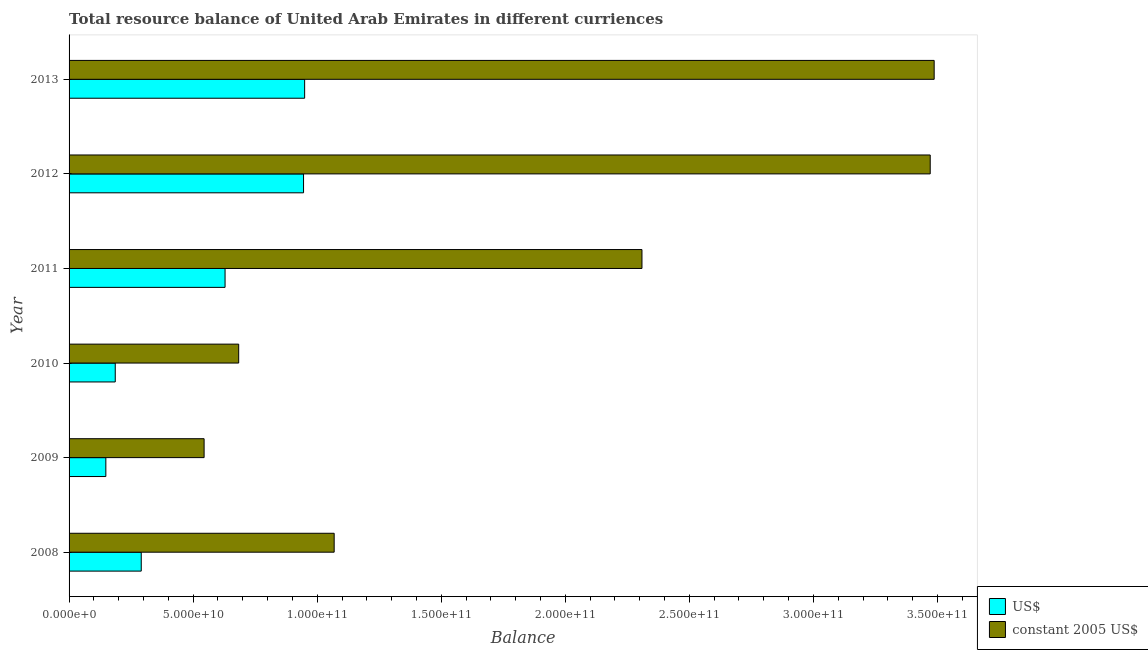How many different coloured bars are there?
Keep it short and to the point. 2. How many groups of bars are there?
Give a very brief answer. 6. What is the label of the 1st group of bars from the top?
Give a very brief answer. 2013. In how many cases, is the number of bars for a given year not equal to the number of legend labels?
Offer a terse response. 0. What is the resource balance in constant us$ in 2012?
Your answer should be compact. 3.47e+11. Across all years, what is the maximum resource balance in us$?
Make the answer very short. 9.49e+1. Across all years, what is the minimum resource balance in constant us$?
Provide a short and direct response. 5.44e+1. In which year was the resource balance in constant us$ minimum?
Make the answer very short. 2009. What is the total resource balance in us$ in the graph?
Provide a short and direct response. 3.15e+11. What is the difference between the resource balance in us$ in 2008 and that in 2012?
Your answer should be compact. -6.54e+1. What is the difference between the resource balance in constant us$ in 2011 and the resource balance in us$ in 2012?
Your response must be concise. 1.36e+11. What is the average resource balance in us$ per year?
Make the answer very short. 5.25e+1. In the year 2013, what is the difference between the resource balance in constant us$ and resource balance in us$?
Provide a short and direct response. 2.54e+11. In how many years, is the resource balance in us$ greater than 180000000000 units?
Provide a succinct answer. 0. What is the ratio of the resource balance in constant us$ in 2010 to that in 2013?
Provide a short and direct response. 0.2. Is the resource balance in us$ in 2008 less than that in 2013?
Ensure brevity in your answer.  Yes. What is the difference between the highest and the second highest resource balance in constant us$?
Keep it short and to the point. 1.60e+09. What is the difference between the highest and the lowest resource balance in constant us$?
Provide a short and direct response. 2.94e+11. In how many years, is the resource balance in us$ greater than the average resource balance in us$ taken over all years?
Your answer should be compact. 3. What does the 1st bar from the top in 2010 represents?
Offer a very short reply. Constant 2005 us$. What does the 1st bar from the bottom in 2009 represents?
Offer a terse response. US$. What is the difference between two consecutive major ticks on the X-axis?
Your answer should be compact. 5.00e+1. Does the graph contain any zero values?
Provide a succinct answer. No. Does the graph contain grids?
Offer a very short reply. No. Where does the legend appear in the graph?
Give a very brief answer. Bottom right. How many legend labels are there?
Keep it short and to the point. 2. How are the legend labels stacked?
Give a very brief answer. Vertical. What is the title of the graph?
Offer a very short reply. Total resource balance of United Arab Emirates in different curriences. Does "Investment" appear as one of the legend labels in the graph?
Provide a succinct answer. No. What is the label or title of the X-axis?
Provide a succinct answer. Balance. What is the Balance in US$ in 2008?
Your answer should be compact. 2.91e+1. What is the Balance of constant 2005 US$ in 2008?
Ensure brevity in your answer.  1.07e+11. What is the Balance of US$ in 2009?
Your answer should be compact. 1.48e+1. What is the Balance of constant 2005 US$ in 2009?
Ensure brevity in your answer.  5.44e+1. What is the Balance in US$ in 2010?
Your response must be concise. 1.86e+1. What is the Balance in constant 2005 US$ in 2010?
Offer a terse response. 6.84e+1. What is the Balance of US$ in 2011?
Your response must be concise. 6.29e+1. What is the Balance of constant 2005 US$ in 2011?
Ensure brevity in your answer.  2.31e+11. What is the Balance of US$ in 2012?
Offer a very short reply. 9.45e+1. What is the Balance of constant 2005 US$ in 2012?
Ensure brevity in your answer.  3.47e+11. What is the Balance in US$ in 2013?
Your answer should be compact. 9.49e+1. What is the Balance in constant 2005 US$ in 2013?
Offer a terse response. 3.49e+11. Across all years, what is the maximum Balance in US$?
Your response must be concise. 9.49e+1. Across all years, what is the maximum Balance of constant 2005 US$?
Give a very brief answer. 3.49e+11. Across all years, what is the minimum Balance in US$?
Offer a terse response. 1.48e+1. Across all years, what is the minimum Balance of constant 2005 US$?
Offer a terse response. 5.44e+1. What is the total Balance of US$ in the graph?
Your answer should be compact. 3.15e+11. What is the total Balance in constant 2005 US$ in the graph?
Your response must be concise. 1.16e+12. What is the difference between the Balance in US$ in 2008 and that in 2009?
Offer a very short reply. 1.43e+1. What is the difference between the Balance of constant 2005 US$ in 2008 and that in 2009?
Your answer should be very brief. 5.24e+1. What is the difference between the Balance in US$ in 2008 and that in 2010?
Your response must be concise. 1.05e+1. What is the difference between the Balance in constant 2005 US$ in 2008 and that in 2010?
Your answer should be compact. 3.85e+1. What is the difference between the Balance in US$ in 2008 and that in 2011?
Your answer should be compact. -3.38e+1. What is the difference between the Balance in constant 2005 US$ in 2008 and that in 2011?
Make the answer very short. -1.24e+11. What is the difference between the Balance of US$ in 2008 and that in 2012?
Your answer should be compact. -6.54e+1. What is the difference between the Balance of constant 2005 US$ in 2008 and that in 2012?
Provide a short and direct response. -2.40e+11. What is the difference between the Balance of US$ in 2008 and that in 2013?
Provide a short and direct response. -6.58e+1. What is the difference between the Balance in constant 2005 US$ in 2008 and that in 2013?
Offer a terse response. -2.42e+11. What is the difference between the Balance of US$ in 2009 and that in 2010?
Your response must be concise. -3.79e+09. What is the difference between the Balance of constant 2005 US$ in 2009 and that in 2010?
Ensure brevity in your answer.  -1.39e+1. What is the difference between the Balance in US$ in 2009 and that in 2011?
Keep it short and to the point. -4.81e+1. What is the difference between the Balance in constant 2005 US$ in 2009 and that in 2011?
Your answer should be compact. -1.76e+11. What is the difference between the Balance of US$ in 2009 and that in 2012?
Give a very brief answer. -7.97e+1. What is the difference between the Balance of constant 2005 US$ in 2009 and that in 2012?
Provide a short and direct response. -2.93e+11. What is the difference between the Balance in US$ in 2009 and that in 2013?
Keep it short and to the point. -8.01e+1. What is the difference between the Balance in constant 2005 US$ in 2009 and that in 2013?
Ensure brevity in your answer.  -2.94e+11. What is the difference between the Balance of US$ in 2010 and that in 2011?
Keep it short and to the point. -4.43e+1. What is the difference between the Balance of constant 2005 US$ in 2010 and that in 2011?
Your response must be concise. -1.63e+11. What is the difference between the Balance of US$ in 2010 and that in 2012?
Your response must be concise. -7.59e+1. What is the difference between the Balance of constant 2005 US$ in 2010 and that in 2012?
Your answer should be compact. -2.79e+11. What is the difference between the Balance in US$ in 2010 and that in 2013?
Your answer should be compact. -7.63e+1. What is the difference between the Balance of constant 2005 US$ in 2010 and that in 2013?
Make the answer very short. -2.80e+11. What is the difference between the Balance in US$ in 2011 and that in 2012?
Your response must be concise. -3.16e+1. What is the difference between the Balance in constant 2005 US$ in 2011 and that in 2012?
Provide a short and direct response. -1.16e+11. What is the difference between the Balance of US$ in 2011 and that in 2013?
Ensure brevity in your answer.  -3.21e+1. What is the difference between the Balance of constant 2005 US$ in 2011 and that in 2013?
Give a very brief answer. -1.18e+11. What is the difference between the Balance in US$ in 2012 and that in 2013?
Offer a terse response. -4.35e+08. What is the difference between the Balance of constant 2005 US$ in 2012 and that in 2013?
Ensure brevity in your answer.  -1.60e+09. What is the difference between the Balance of US$ in 2008 and the Balance of constant 2005 US$ in 2009?
Provide a succinct answer. -2.53e+1. What is the difference between the Balance in US$ in 2008 and the Balance in constant 2005 US$ in 2010?
Provide a succinct answer. -3.93e+1. What is the difference between the Balance of US$ in 2008 and the Balance of constant 2005 US$ in 2011?
Give a very brief answer. -2.02e+11. What is the difference between the Balance in US$ in 2008 and the Balance in constant 2005 US$ in 2012?
Make the answer very short. -3.18e+11. What is the difference between the Balance in US$ in 2008 and the Balance in constant 2005 US$ in 2013?
Give a very brief answer. -3.20e+11. What is the difference between the Balance in US$ in 2009 and the Balance in constant 2005 US$ in 2010?
Give a very brief answer. -5.35e+1. What is the difference between the Balance in US$ in 2009 and the Balance in constant 2005 US$ in 2011?
Offer a very short reply. -2.16e+11. What is the difference between the Balance in US$ in 2009 and the Balance in constant 2005 US$ in 2012?
Give a very brief answer. -3.32e+11. What is the difference between the Balance in US$ in 2009 and the Balance in constant 2005 US$ in 2013?
Offer a terse response. -3.34e+11. What is the difference between the Balance in US$ in 2010 and the Balance in constant 2005 US$ in 2011?
Your answer should be compact. -2.12e+11. What is the difference between the Balance in US$ in 2010 and the Balance in constant 2005 US$ in 2012?
Offer a terse response. -3.28e+11. What is the difference between the Balance of US$ in 2010 and the Balance of constant 2005 US$ in 2013?
Ensure brevity in your answer.  -3.30e+11. What is the difference between the Balance in US$ in 2011 and the Balance in constant 2005 US$ in 2012?
Your answer should be very brief. -2.84e+11. What is the difference between the Balance in US$ in 2011 and the Balance in constant 2005 US$ in 2013?
Provide a succinct answer. -2.86e+11. What is the difference between the Balance in US$ in 2012 and the Balance in constant 2005 US$ in 2013?
Offer a very short reply. -2.54e+11. What is the average Balance in US$ per year?
Ensure brevity in your answer.  5.25e+1. What is the average Balance in constant 2005 US$ per year?
Your answer should be compact. 1.93e+11. In the year 2008, what is the difference between the Balance of US$ and Balance of constant 2005 US$?
Provide a succinct answer. -7.78e+1. In the year 2009, what is the difference between the Balance of US$ and Balance of constant 2005 US$?
Ensure brevity in your answer.  -3.96e+1. In the year 2010, what is the difference between the Balance in US$ and Balance in constant 2005 US$?
Provide a short and direct response. -4.97e+1. In the year 2011, what is the difference between the Balance in US$ and Balance in constant 2005 US$?
Your answer should be very brief. -1.68e+11. In the year 2012, what is the difference between the Balance of US$ and Balance of constant 2005 US$?
Make the answer very short. -2.53e+11. In the year 2013, what is the difference between the Balance in US$ and Balance in constant 2005 US$?
Your answer should be very brief. -2.54e+11. What is the ratio of the Balance of US$ in 2008 to that in 2009?
Your response must be concise. 1.96. What is the ratio of the Balance of constant 2005 US$ in 2008 to that in 2009?
Provide a short and direct response. 1.96. What is the ratio of the Balance of US$ in 2008 to that in 2010?
Your answer should be very brief. 1.56. What is the ratio of the Balance of constant 2005 US$ in 2008 to that in 2010?
Ensure brevity in your answer.  1.56. What is the ratio of the Balance of US$ in 2008 to that in 2011?
Ensure brevity in your answer.  0.46. What is the ratio of the Balance in constant 2005 US$ in 2008 to that in 2011?
Your answer should be very brief. 0.46. What is the ratio of the Balance in US$ in 2008 to that in 2012?
Give a very brief answer. 0.31. What is the ratio of the Balance of constant 2005 US$ in 2008 to that in 2012?
Provide a succinct answer. 0.31. What is the ratio of the Balance in US$ in 2008 to that in 2013?
Give a very brief answer. 0.31. What is the ratio of the Balance of constant 2005 US$ in 2008 to that in 2013?
Keep it short and to the point. 0.31. What is the ratio of the Balance of US$ in 2009 to that in 2010?
Offer a terse response. 0.8. What is the ratio of the Balance in constant 2005 US$ in 2009 to that in 2010?
Offer a very short reply. 0.8. What is the ratio of the Balance in US$ in 2009 to that in 2011?
Ensure brevity in your answer.  0.24. What is the ratio of the Balance in constant 2005 US$ in 2009 to that in 2011?
Your response must be concise. 0.24. What is the ratio of the Balance in US$ in 2009 to that in 2012?
Provide a short and direct response. 0.16. What is the ratio of the Balance of constant 2005 US$ in 2009 to that in 2012?
Provide a succinct answer. 0.16. What is the ratio of the Balance of US$ in 2009 to that in 2013?
Your answer should be very brief. 0.16. What is the ratio of the Balance in constant 2005 US$ in 2009 to that in 2013?
Your answer should be compact. 0.16. What is the ratio of the Balance of US$ in 2010 to that in 2011?
Your response must be concise. 0.3. What is the ratio of the Balance in constant 2005 US$ in 2010 to that in 2011?
Provide a short and direct response. 0.3. What is the ratio of the Balance in US$ in 2010 to that in 2012?
Give a very brief answer. 0.2. What is the ratio of the Balance in constant 2005 US$ in 2010 to that in 2012?
Keep it short and to the point. 0.2. What is the ratio of the Balance in US$ in 2010 to that in 2013?
Offer a very short reply. 0.2. What is the ratio of the Balance of constant 2005 US$ in 2010 to that in 2013?
Make the answer very short. 0.2. What is the ratio of the Balance of US$ in 2011 to that in 2012?
Offer a terse response. 0.67. What is the ratio of the Balance in constant 2005 US$ in 2011 to that in 2012?
Offer a terse response. 0.67. What is the ratio of the Balance in US$ in 2011 to that in 2013?
Provide a succinct answer. 0.66. What is the ratio of the Balance in constant 2005 US$ in 2011 to that in 2013?
Your answer should be compact. 0.66. What is the ratio of the Balance of constant 2005 US$ in 2012 to that in 2013?
Your answer should be compact. 1. What is the difference between the highest and the second highest Balance in US$?
Provide a short and direct response. 4.35e+08. What is the difference between the highest and the second highest Balance of constant 2005 US$?
Provide a short and direct response. 1.60e+09. What is the difference between the highest and the lowest Balance of US$?
Ensure brevity in your answer.  8.01e+1. What is the difference between the highest and the lowest Balance of constant 2005 US$?
Offer a terse response. 2.94e+11. 